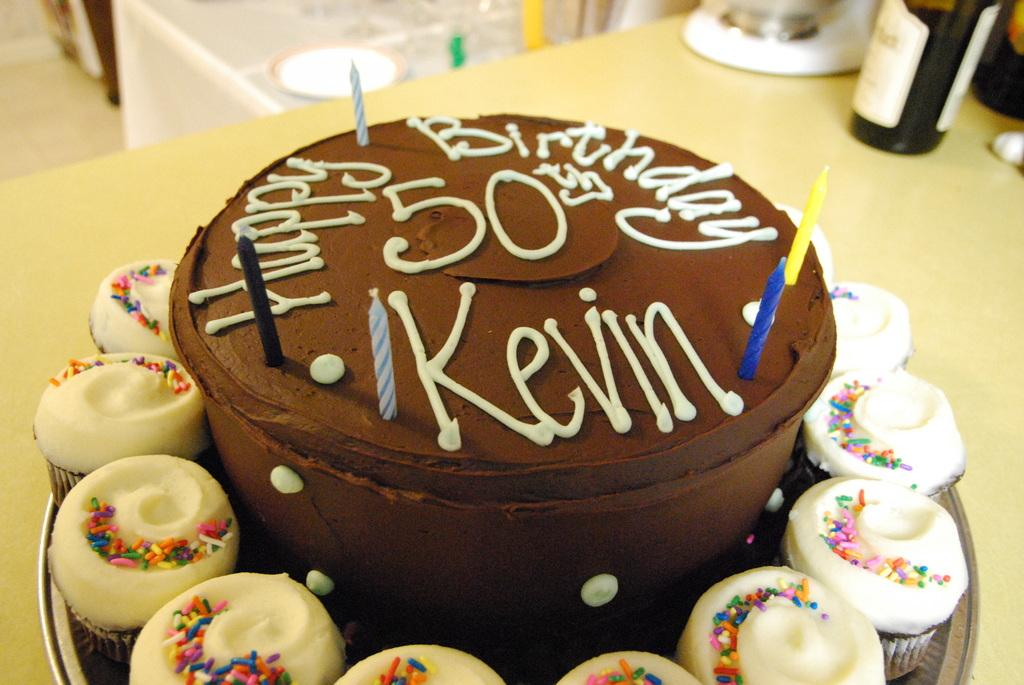What type of dessert is the main focus of the image? There is a cake in the image. Are there any other desserts visible in the image? Yes, there are cupcakes on the plate. What is placed on top of the cake? The cake has candles on it. What is the plate resting on in the image? The plate is on an object. What else can be seen on the object? There is a bottle and other things on the object. What is the condition of the brake in the image? There is no brake present in the image. How does the lock on the cupcakes work? There are no locks on the cupcakes in the image. 